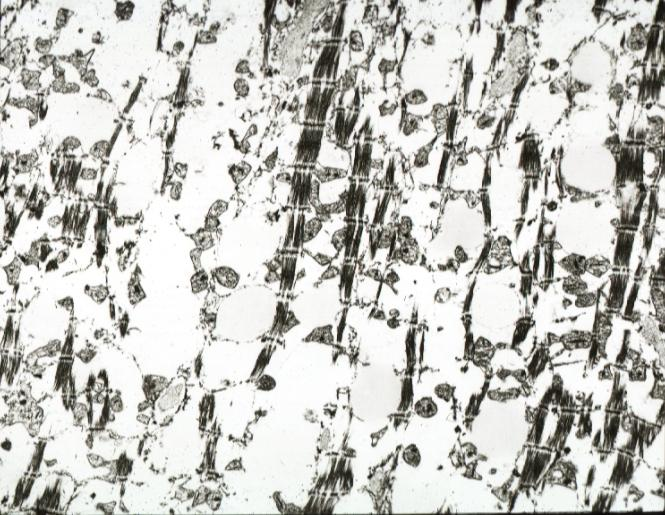what is present?
Answer the question using a single word or phrase. Cardiovascular 